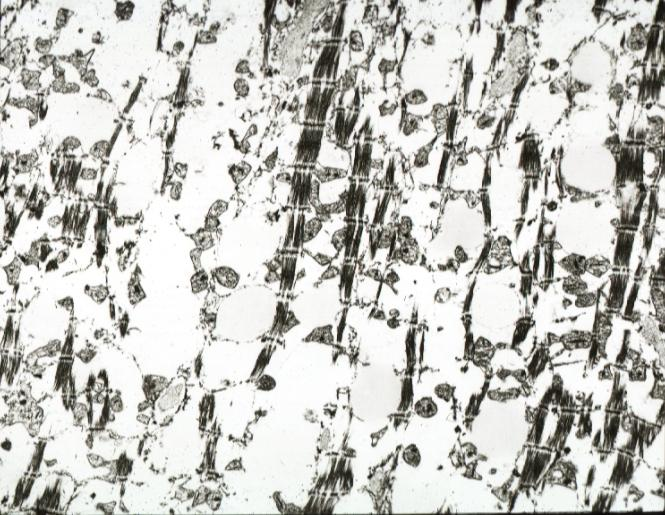what is present?
Answer the question using a single word or phrase. Cardiovascular 